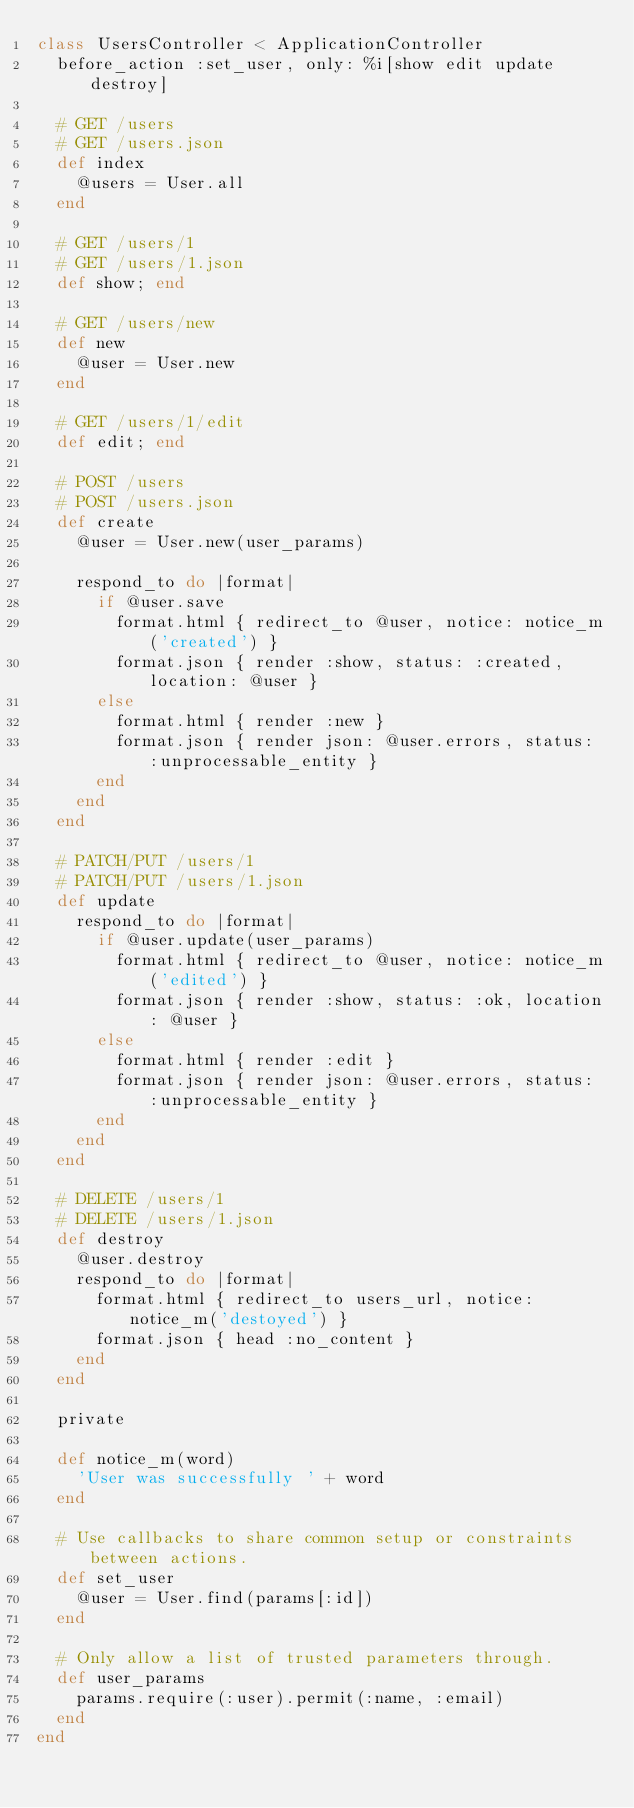<code> <loc_0><loc_0><loc_500><loc_500><_Ruby_>class UsersController < ApplicationController
  before_action :set_user, only: %i[show edit update destroy]

  # GET /users
  # GET /users.json
  def index
    @users = User.all
  end

  # GET /users/1
  # GET /users/1.json
  def show; end

  # GET /users/new
  def new
    @user = User.new
  end

  # GET /users/1/edit
  def edit; end

  # POST /users
  # POST /users.json
  def create
    @user = User.new(user_params)

    respond_to do |format|
      if @user.save
        format.html { redirect_to @user, notice: notice_m('created') }
        format.json { render :show, status: :created, location: @user }
      else
        format.html { render :new }
        format.json { render json: @user.errors, status: :unprocessable_entity }
      end
    end
  end

  # PATCH/PUT /users/1
  # PATCH/PUT /users/1.json
  def update
    respond_to do |format|
      if @user.update(user_params)
        format.html { redirect_to @user, notice: notice_m('edited') }
        format.json { render :show, status: :ok, location: @user }
      else
        format.html { render :edit }
        format.json { render json: @user.errors, status: :unprocessable_entity }
      end
    end
  end

  # DELETE /users/1
  # DELETE /users/1.json
  def destroy
    @user.destroy
    respond_to do |format|
      format.html { redirect_to users_url, notice: notice_m('destoyed') }
      format.json { head :no_content }
    end
  end

  private

  def notice_m(word)
    'User was successfully ' + word
  end

  # Use callbacks to share common setup or constraints between actions.
  def set_user
    @user = User.find(params[:id])
  end

  # Only allow a list of trusted parameters through.
  def user_params
    params.require(:user).permit(:name, :email)
  end
end
</code> 